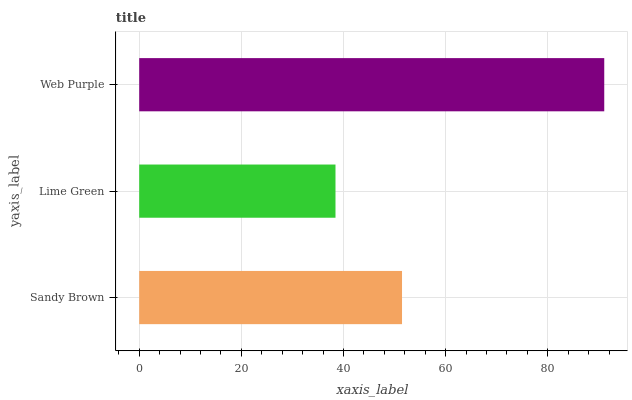Is Lime Green the minimum?
Answer yes or no. Yes. Is Web Purple the maximum?
Answer yes or no. Yes. Is Web Purple the minimum?
Answer yes or no. No. Is Lime Green the maximum?
Answer yes or no. No. Is Web Purple greater than Lime Green?
Answer yes or no. Yes. Is Lime Green less than Web Purple?
Answer yes or no. Yes. Is Lime Green greater than Web Purple?
Answer yes or no. No. Is Web Purple less than Lime Green?
Answer yes or no. No. Is Sandy Brown the high median?
Answer yes or no. Yes. Is Sandy Brown the low median?
Answer yes or no. Yes. Is Web Purple the high median?
Answer yes or no. No. Is Web Purple the low median?
Answer yes or no. No. 